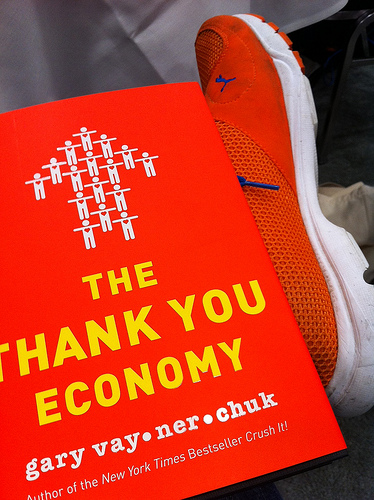<image>
Is the book on the shoe? Yes. Looking at the image, I can see the book is positioned on top of the shoe, with the shoe providing support. Is the person in the arrow? Yes. The person is contained within or inside the arrow, showing a containment relationship. 